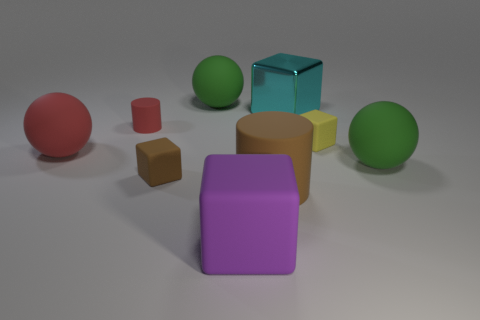Are there any rubber cubes on the left side of the metal block that is to the right of the brown matte cylinder?
Make the answer very short. Yes. How many other things are the same color as the big cylinder?
Make the answer very short. 1. The tiny matte cylinder is what color?
Keep it short and to the point. Red. There is a matte object that is in front of the yellow matte cube and on the left side of the brown rubber block; how big is it?
Your answer should be compact. Large. How many objects are either rubber spheres that are behind the red cylinder or tiny green metal things?
Give a very brief answer. 1. What is the shape of the large red object that is the same material as the tiny red cylinder?
Your answer should be very brief. Sphere. The large cyan object is what shape?
Offer a very short reply. Cube. What is the color of the matte thing that is in front of the red matte ball and right of the large cyan cube?
Keep it short and to the point. Green. The red object that is the same size as the brown matte cylinder is what shape?
Offer a terse response. Sphere. Is there a tiny brown object of the same shape as the large shiny object?
Your answer should be compact. Yes. 